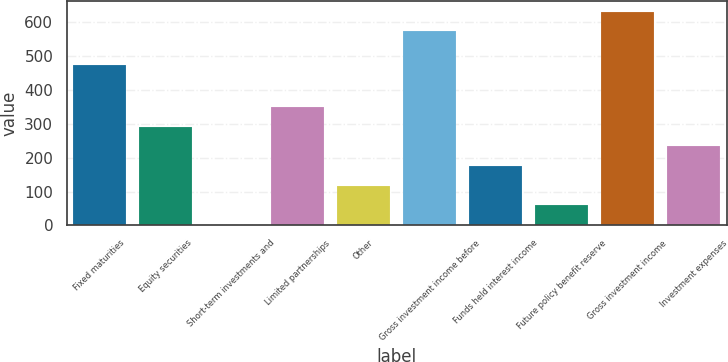Convert chart. <chart><loc_0><loc_0><loc_500><loc_500><bar_chart><fcel>Fixed maturities<fcel>Equity securities<fcel>Short-term investments and<fcel>Limited partnerships<fcel>Other<fcel>Gross investment income before<fcel>Funds held interest income<fcel>Future policy benefit reserve<fcel>Gross investment income<fcel>Investment expenses<nl><fcel>473.5<fcel>291.8<fcel>1.3<fcel>349.9<fcel>117.5<fcel>574.4<fcel>175.6<fcel>59.4<fcel>632.5<fcel>233.7<nl></chart> 